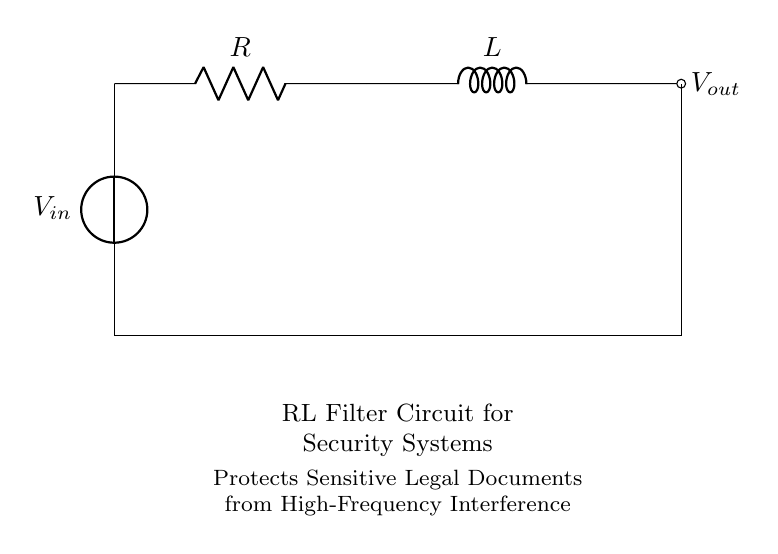What type of circuit is depicted in the diagram? The diagram shows an RL filter circuit, which is characterized by the presence of a resistor and an inductor in series.
Answer: RL filter circuit What are the components used in this circuit? The circuit consists of a voltage source, a resistor, and an inductor, as indicated by their symbols in the diagram.
Answer: Voltage source, resistor, inductor What does the input voltage represent in the circuit? The input voltage represents the voltage supplied to the input of the circuit, which is essential for powering the circuit and initiating current flow.
Answer: Voltage supplied What is the purpose of this RL filter circuit? The purpose of this circuit is to protect sensitive legal documents from high-frequency interference by filtering out unwanted frequencies, allowing only lower frequencies to pass through.
Answer: To protect sensitive documents How does the presence of an inductor affect the circuit's response? The inductor introduces reactance, which impedes changes in current and creates a phase shift in the output voltage relative to the input, thus influencing the filtering characteristics of the circuit.
Answer: Impedes current changes What can you infer about the output voltage in relation to the input voltage in this circuit? The output voltage is typically lower than the input voltage for higher frequencies due to the filtering effect of the inductor, which allows only certain frequencies to pass while attenuating others.
Answer: Output voltage lower for high frequencies 